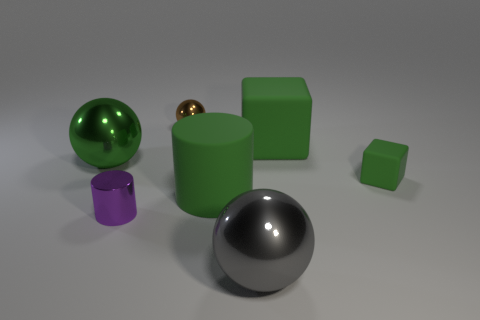Add 1 big metal objects. How many objects exist? 8 Subtract all balls. How many objects are left? 4 Subtract 1 brown balls. How many objects are left? 6 Subtract all small matte cylinders. Subtract all brown objects. How many objects are left? 6 Add 6 large gray shiny things. How many large gray shiny things are left? 7 Add 7 small yellow shiny objects. How many small yellow shiny objects exist? 7 